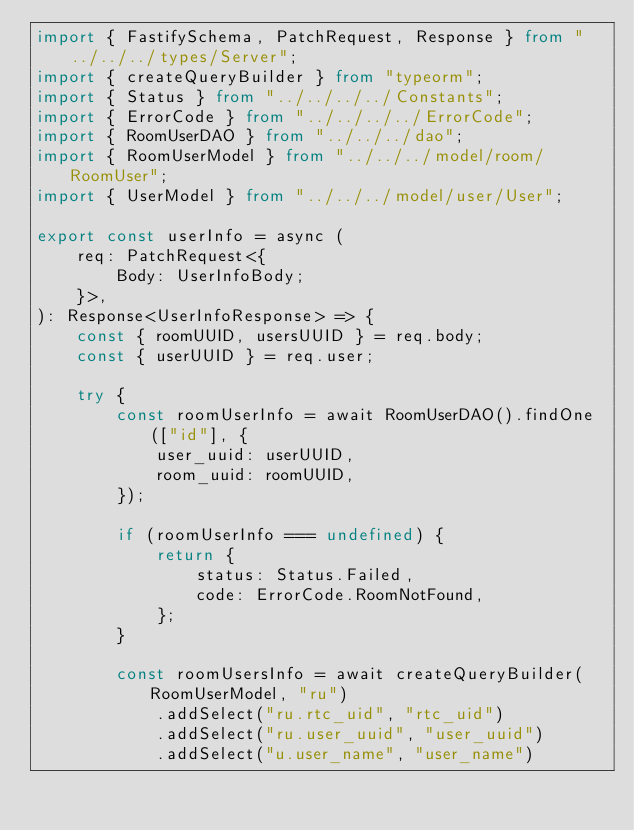Convert code to text. <code><loc_0><loc_0><loc_500><loc_500><_TypeScript_>import { FastifySchema, PatchRequest, Response } from "../../../types/Server";
import { createQueryBuilder } from "typeorm";
import { Status } from "../../../../Constants";
import { ErrorCode } from "../../../../ErrorCode";
import { RoomUserDAO } from "../../../dao";
import { RoomUserModel } from "../../../model/room/RoomUser";
import { UserModel } from "../../../model/user/User";

export const userInfo = async (
    req: PatchRequest<{
        Body: UserInfoBody;
    }>,
): Response<UserInfoResponse> => {
    const { roomUUID, usersUUID } = req.body;
    const { userUUID } = req.user;

    try {
        const roomUserInfo = await RoomUserDAO().findOne(["id"], {
            user_uuid: userUUID,
            room_uuid: roomUUID,
        });

        if (roomUserInfo === undefined) {
            return {
                status: Status.Failed,
                code: ErrorCode.RoomNotFound,
            };
        }

        const roomUsersInfo = await createQueryBuilder(RoomUserModel, "ru")
            .addSelect("ru.rtc_uid", "rtc_uid")
            .addSelect("ru.user_uuid", "user_uuid")
            .addSelect("u.user_name", "user_name")</code> 